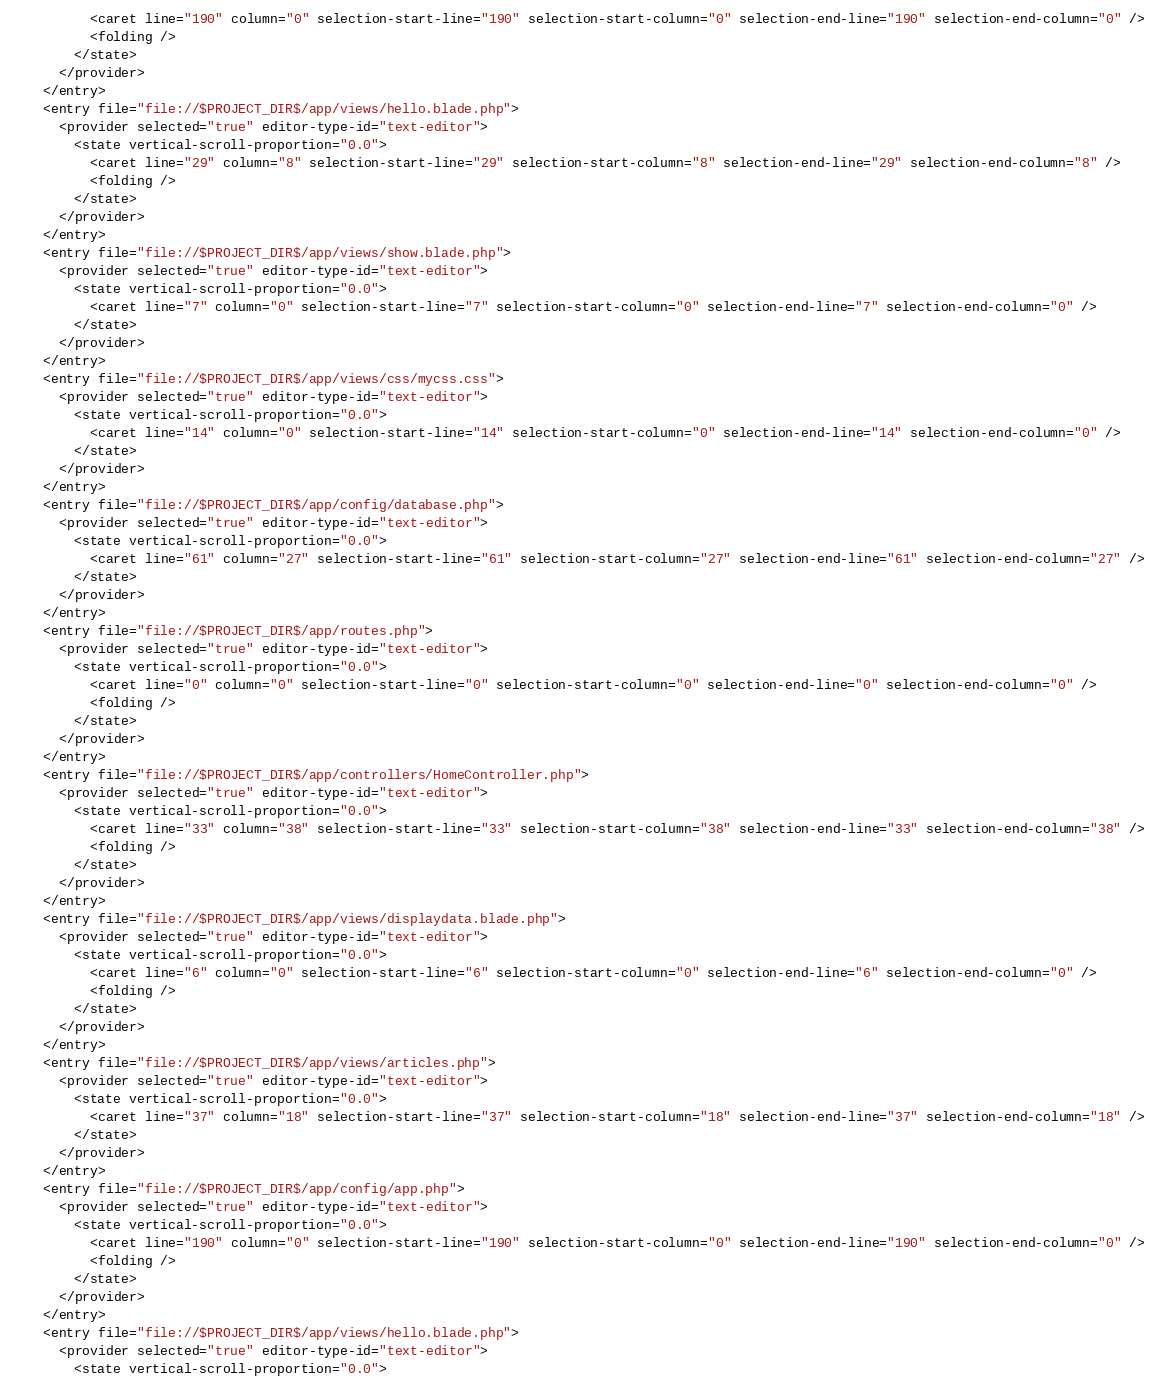<code> <loc_0><loc_0><loc_500><loc_500><_XML_>          <caret line="190" column="0" selection-start-line="190" selection-start-column="0" selection-end-line="190" selection-end-column="0" />
          <folding />
        </state>
      </provider>
    </entry>
    <entry file="file://$PROJECT_DIR$/app/views/hello.blade.php">
      <provider selected="true" editor-type-id="text-editor">
        <state vertical-scroll-proportion="0.0">
          <caret line="29" column="8" selection-start-line="29" selection-start-column="8" selection-end-line="29" selection-end-column="8" />
          <folding />
        </state>
      </provider>
    </entry>
    <entry file="file://$PROJECT_DIR$/app/views/show.blade.php">
      <provider selected="true" editor-type-id="text-editor">
        <state vertical-scroll-proportion="0.0">
          <caret line="7" column="0" selection-start-line="7" selection-start-column="0" selection-end-line="7" selection-end-column="0" />
        </state>
      </provider>
    </entry>
    <entry file="file://$PROJECT_DIR$/app/views/css/mycss.css">
      <provider selected="true" editor-type-id="text-editor">
        <state vertical-scroll-proportion="0.0">
          <caret line="14" column="0" selection-start-line="14" selection-start-column="0" selection-end-line="14" selection-end-column="0" />
        </state>
      </provider>
    </entry>
    <entry file="file://$PROJECT_DIR$/app/config/database.php">
      <provider selected="true" editor-type-id="text-editor">
        <state vertical-scroll-proportion="0.0">
          <caret line="61" column="27" selection-start-line="61" selection-start-column="27" selection-end-line="61" selection-end-column="27" />
        </state>
      </provider>
    </entry>
    <entry file="file://$PROJECT_DIR$/app/routes.php">
      <provider selected="true" editor-type-id="text-editor">
        <state vertical-scroll-proportion="0.0">
          <caret line="0" column="0" selection-start-line="0" selection-start-column="0" selection-end-line="0" selection-end-column="0" />
          <folding />
        </state>
      </provider>
    </entry>
    <entry file="file://$PROJECT_DIR$/app/controllers/HomeController.php">
      <provider selected="true" editor-type-id="text-editor">
        <state vertical-scroll-proportion="0.0">
          <caret line="33" column="38" selection-start-line="33" selection-start-column="38" selection-end-line="33" selection-end-column="38" />
          <folding />
        </state>
      </provider>
    </entry>
    <entry file="file://$PROJECT_DIR$/app/views/displaydata.blade.php">
      <provider selected="true" editor-type-id="text-editor">
        <state vertical-scroll-proportion="0.0">
          <caret line="6" column="0" selection-start-line="6" selection-start-column="0" selection-end-line="6" selection-end-column="0" />
          <folding />
        </state>
      </provider>
    </entry>
    <entry file="file://$PROJECT_DIR$/app/views/articles.php">
      <provider selected="true" editor-type-id="text-editor">
        <state vertical-scroll-proportion="0.0">
          <caret line="37" column="18" selection-start-line="37" selection-start-column="18" selection-end-line="37" selection-end-column="18" />
        </state>
      </provider>
    </entry>
    <entry file="file://$PROJECT_DIR$/app/config/app.php">
      <provider selected="true" editor-type-id="text-editor">
        <state vertical-scroll-proportion="0.0">
          <caret line="190" column="0" selection-start-line="190" selection-start-column="0" selection-end-line="190" selection-end-column="0" />
          <folding />
        </state>
      </provider>
    </entry>
    <entry file="file://$PROJECT_DIR$/app/views/hello.blade.php">
      <provider selected="true" editor-type-id="text-editor">
        <state vertical-scroll-proportion="0.0"></code> 